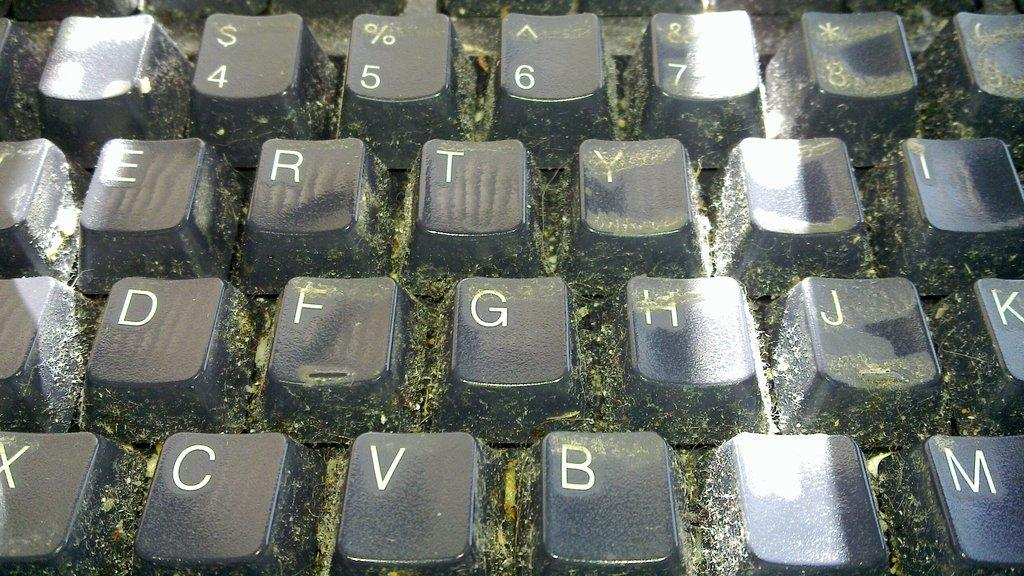<image>
Summarize the visual content of the image. a keyboard with the number 5 at the top 